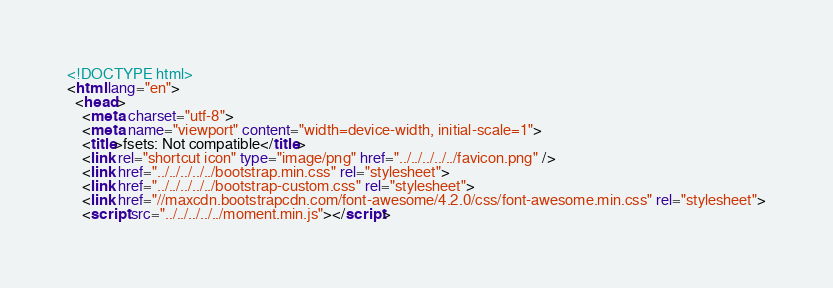Convert code to text. <code><loc_0><loc_0><loc_500><loc_500><_HTML_><!DOCTYPE html>
<html lang="en">
  <head>
    <meta charset="utf-8">
    <meta name="viewport" content="width=device-width, initial-scale=1">
    <title>fsets: Not compatible</title>
    <link rel="shortcut icon" type="image/png" href="../../../../../favicon.png" />
    <link href="../../../../../bootstrap.min.css" rel="stylesheet">
    <link href="../../../../../bootstrap-custom.css" rel="stylesheet">
    <link href="//maxcdn.bootstrapcdn.com/font-awesome/4.2.0/css/font-awesome.min.css" rel="stylesheet">
    <script src="../../../../../moment.min.js"></script></code> 